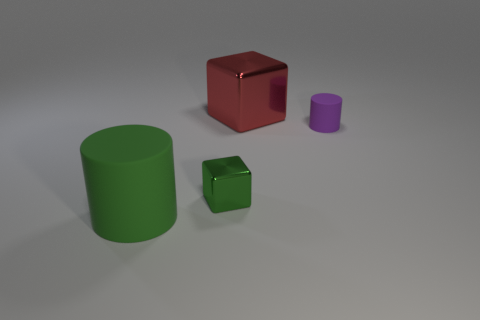How many blocks have the same size as the purple object?
Your answer should be compact. 1. There is a cylinder on the left side of the purple rubber thing; what number of small green cubes are on the left side of it?
Your response must be concise. 0. Do the green object to the right of the big green rubber object and the purple thing have the same material?
Provide a short and direct response. No. Is the object that is right of the red object made of the same material as the cylinder left of the big red shiny cube?
Give a very brief answer. Yes. Is the number of big green cylinders in front of the big metallic cube greater than the number of tiny blue metallic cylinders?
Your answer should be compact. Yes. There is a cylinder behind the shiny thing in front of the big shiny object; what is its color?
Provide a succinct answer. Purple. There is another object that is the same size as the purple thing; what is its shape?
Offer a terse response. Cube. What is the shape of the object that is the same color as the tiny shiny block?
Make the answer very short. Cylinder. Is the number of small matte cylinders that are on the right side of the large green cylinder the same as the number of red cylinders?
Make the answer very short. No. What is the large thing to the right of the matte cylinder that is in front of the thing that is to the right of the big red metal object made of?
Your answer should be compact. Metal. 